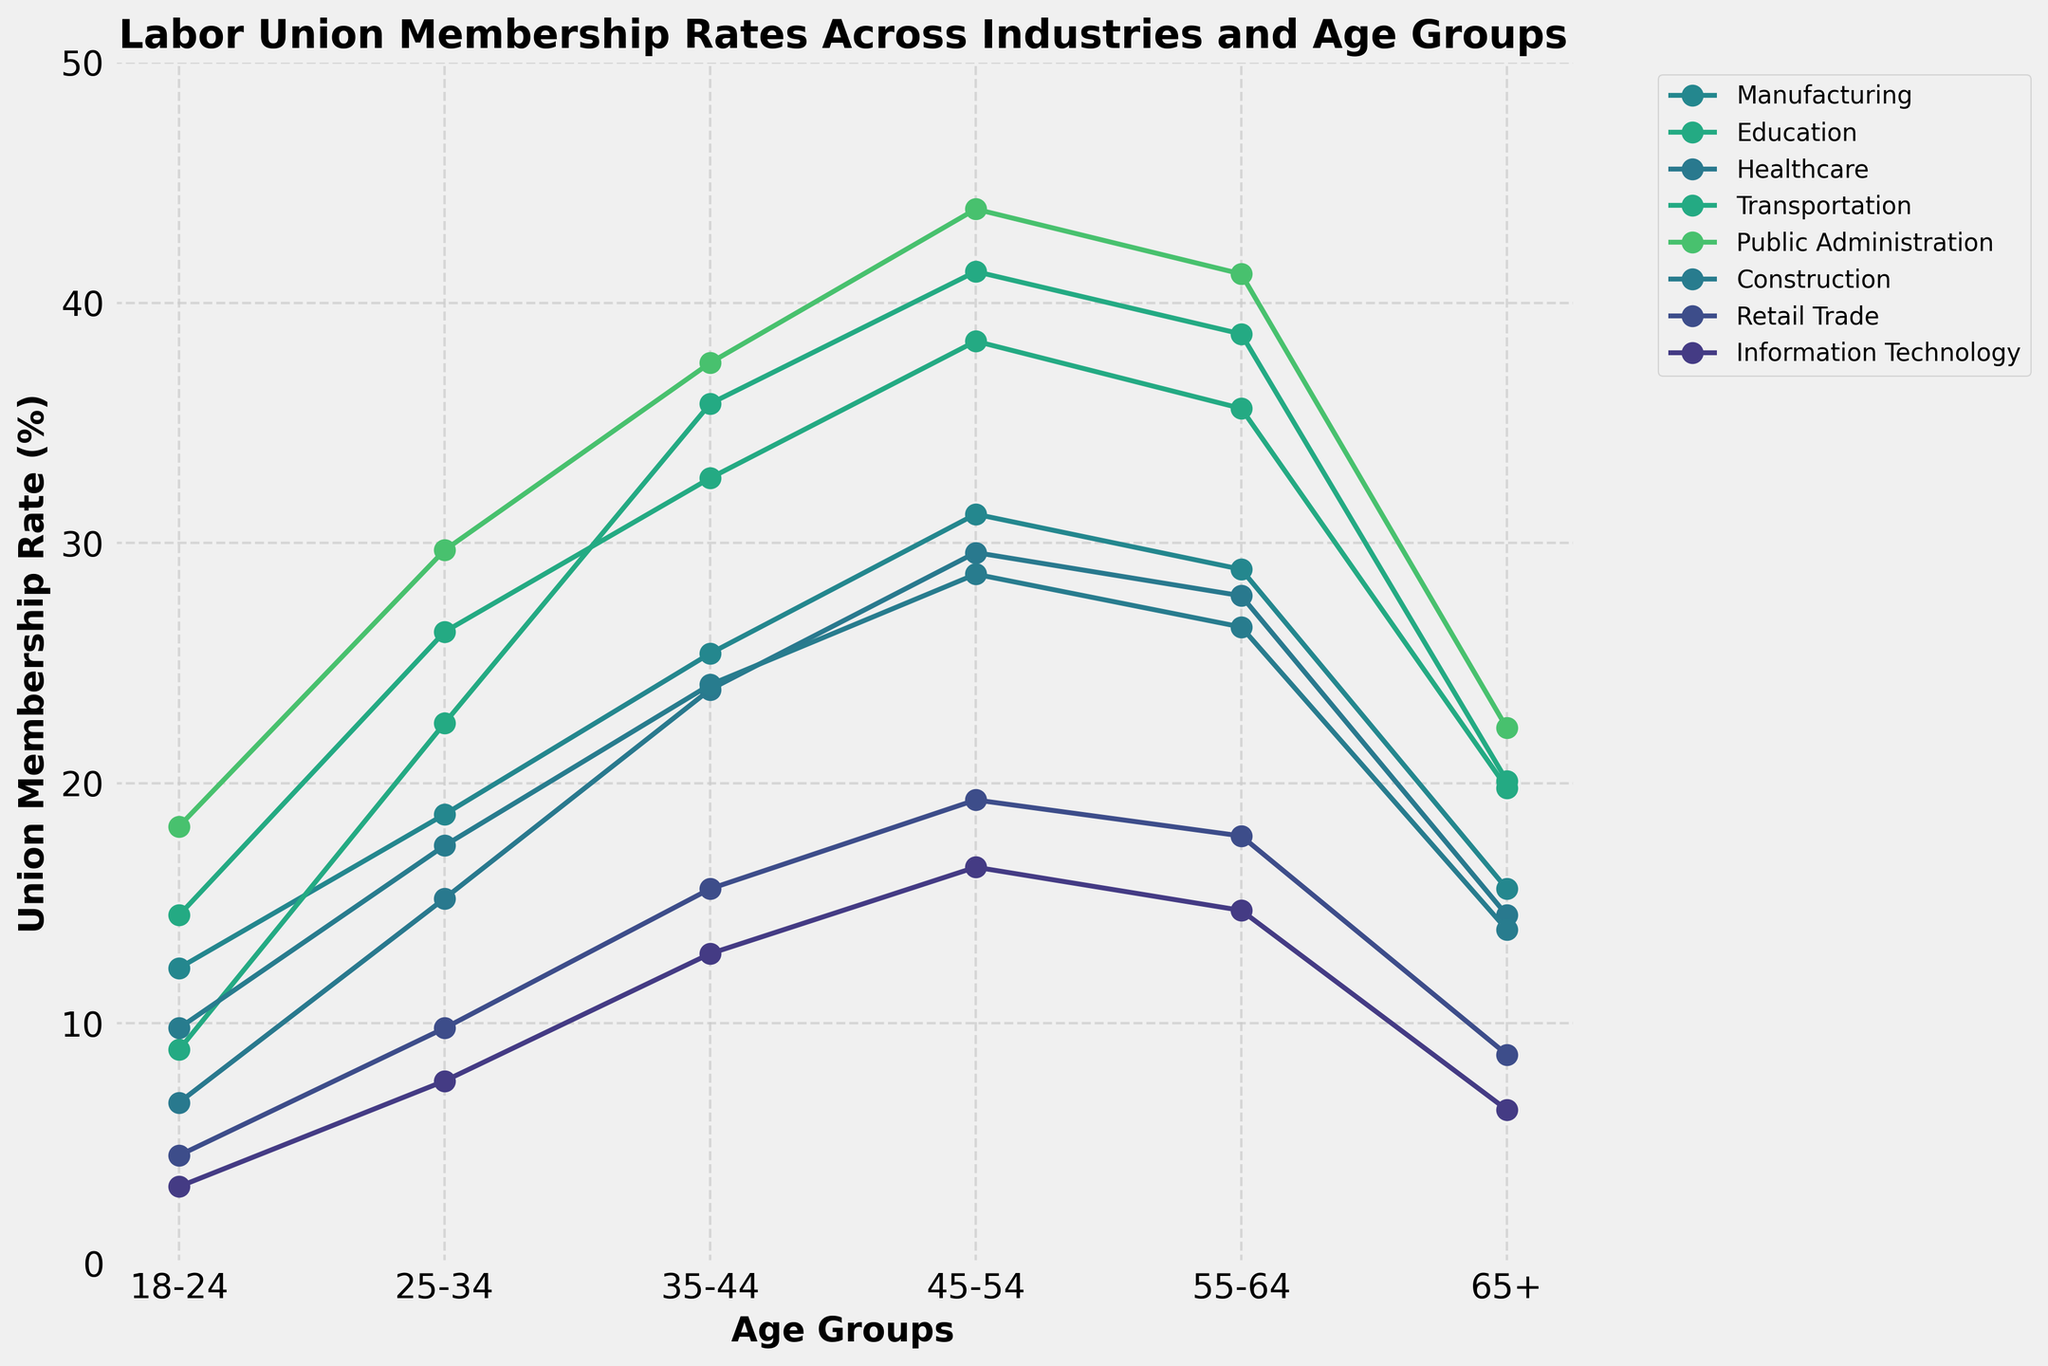What's the highest union membership rate shown in the plot? Looking at the y-axis, the highest union membership rate is found by locating the tallest point on the plot, which is for "Public Administration" in the 45-54 age group. This rate reaches approximately 43.9%.
Answer: 43.9% Which industry has the lowest union membership rate for the 18-24 age group? To determine this, find the 18-24 age group on the x-axis and observe the corresponding points. The "Information Technology" industry has the lowest membership rate for this age group at 3.2%.
Answer: Information Technology How does the union membership rate in the Education industry for the 45-54 age group compare to the rate in the Retail Trade industry for the same age group? Locate both industries on the plot at the 45-54 age group on the x-axis. The membership rate for Education is 41.3%, while for Retail Trade, it is 19.3%. Thus, the rate in Education is higher.
Answer: Education is higher What's the average union membership rate in the Healthcare industry across all age groups? To calculate this, sum the Healthcare membership rates (6.7 + 15.2 + 23.9 + 29.6 + 27.8 + 14.5) and divide by the number of age groups (6). The sum is 117.7, so the average rate is 117.7 / 6 = 19.62%.
Answer: 19.62% Between the Construction and Manufacturing industries, which one shows a steeper increase in union membership rates from the 18-24 to the 45-54 age groups? Calculate the rate changes for both industries: Construction increases from 9.8% to 28.7%, a difference of 18.9%. Manufacturing increases from 12.3% to 31.2%, a difference of 18.9%. Both industries actually show the same increase.
Answer: Both increase the same Which industry shows the highest union membership rate for the 65+ age group? Locate the 65+ age group on the x-axis and observe the highest point among all industries. "Public Administration" has the highest rate at 22.3%.
Answer: Public Administration What is the trend of union membership rates for the Transportation industry across different age groups? Follow the Transportation industry line across the x-axis. Union membership rates steadily increase from 14.5% at 18-24 to 35.6% at 55-64, and then slightly drop to 19.8% for the 65+ age group.
Answer: Increasing then decreasing Among all industries, which one exhibits the most significant decline in union membership rates between the 55-64 and 65+ age groups? Compare the rates for all industries between these age groups. The Education industry shows the most significant decline, dropping from 38.7% to 20.1%, a difference of 18.6%.
Answer: Education 